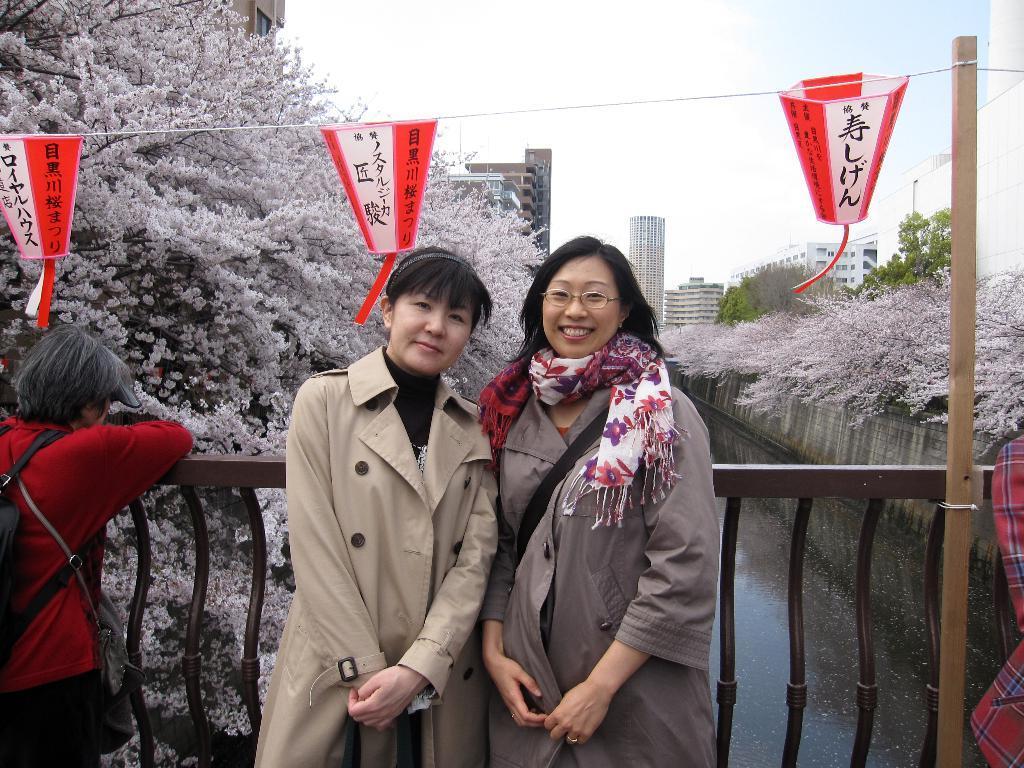In one or two sentences, can you explain what this image depicts? In this picture there are two women who are standing near to the fencing and both of them are smiling. On the left there is a man who is wearing red t-shirt, bag and trouser. In the back I can see the white color and green color trees. In the background I can see the skyscrapers buildings and poles. In the center I can see the red color flags which are placed on this road. At the bottom I can see the water. At the top i can see the sky and clouds. 